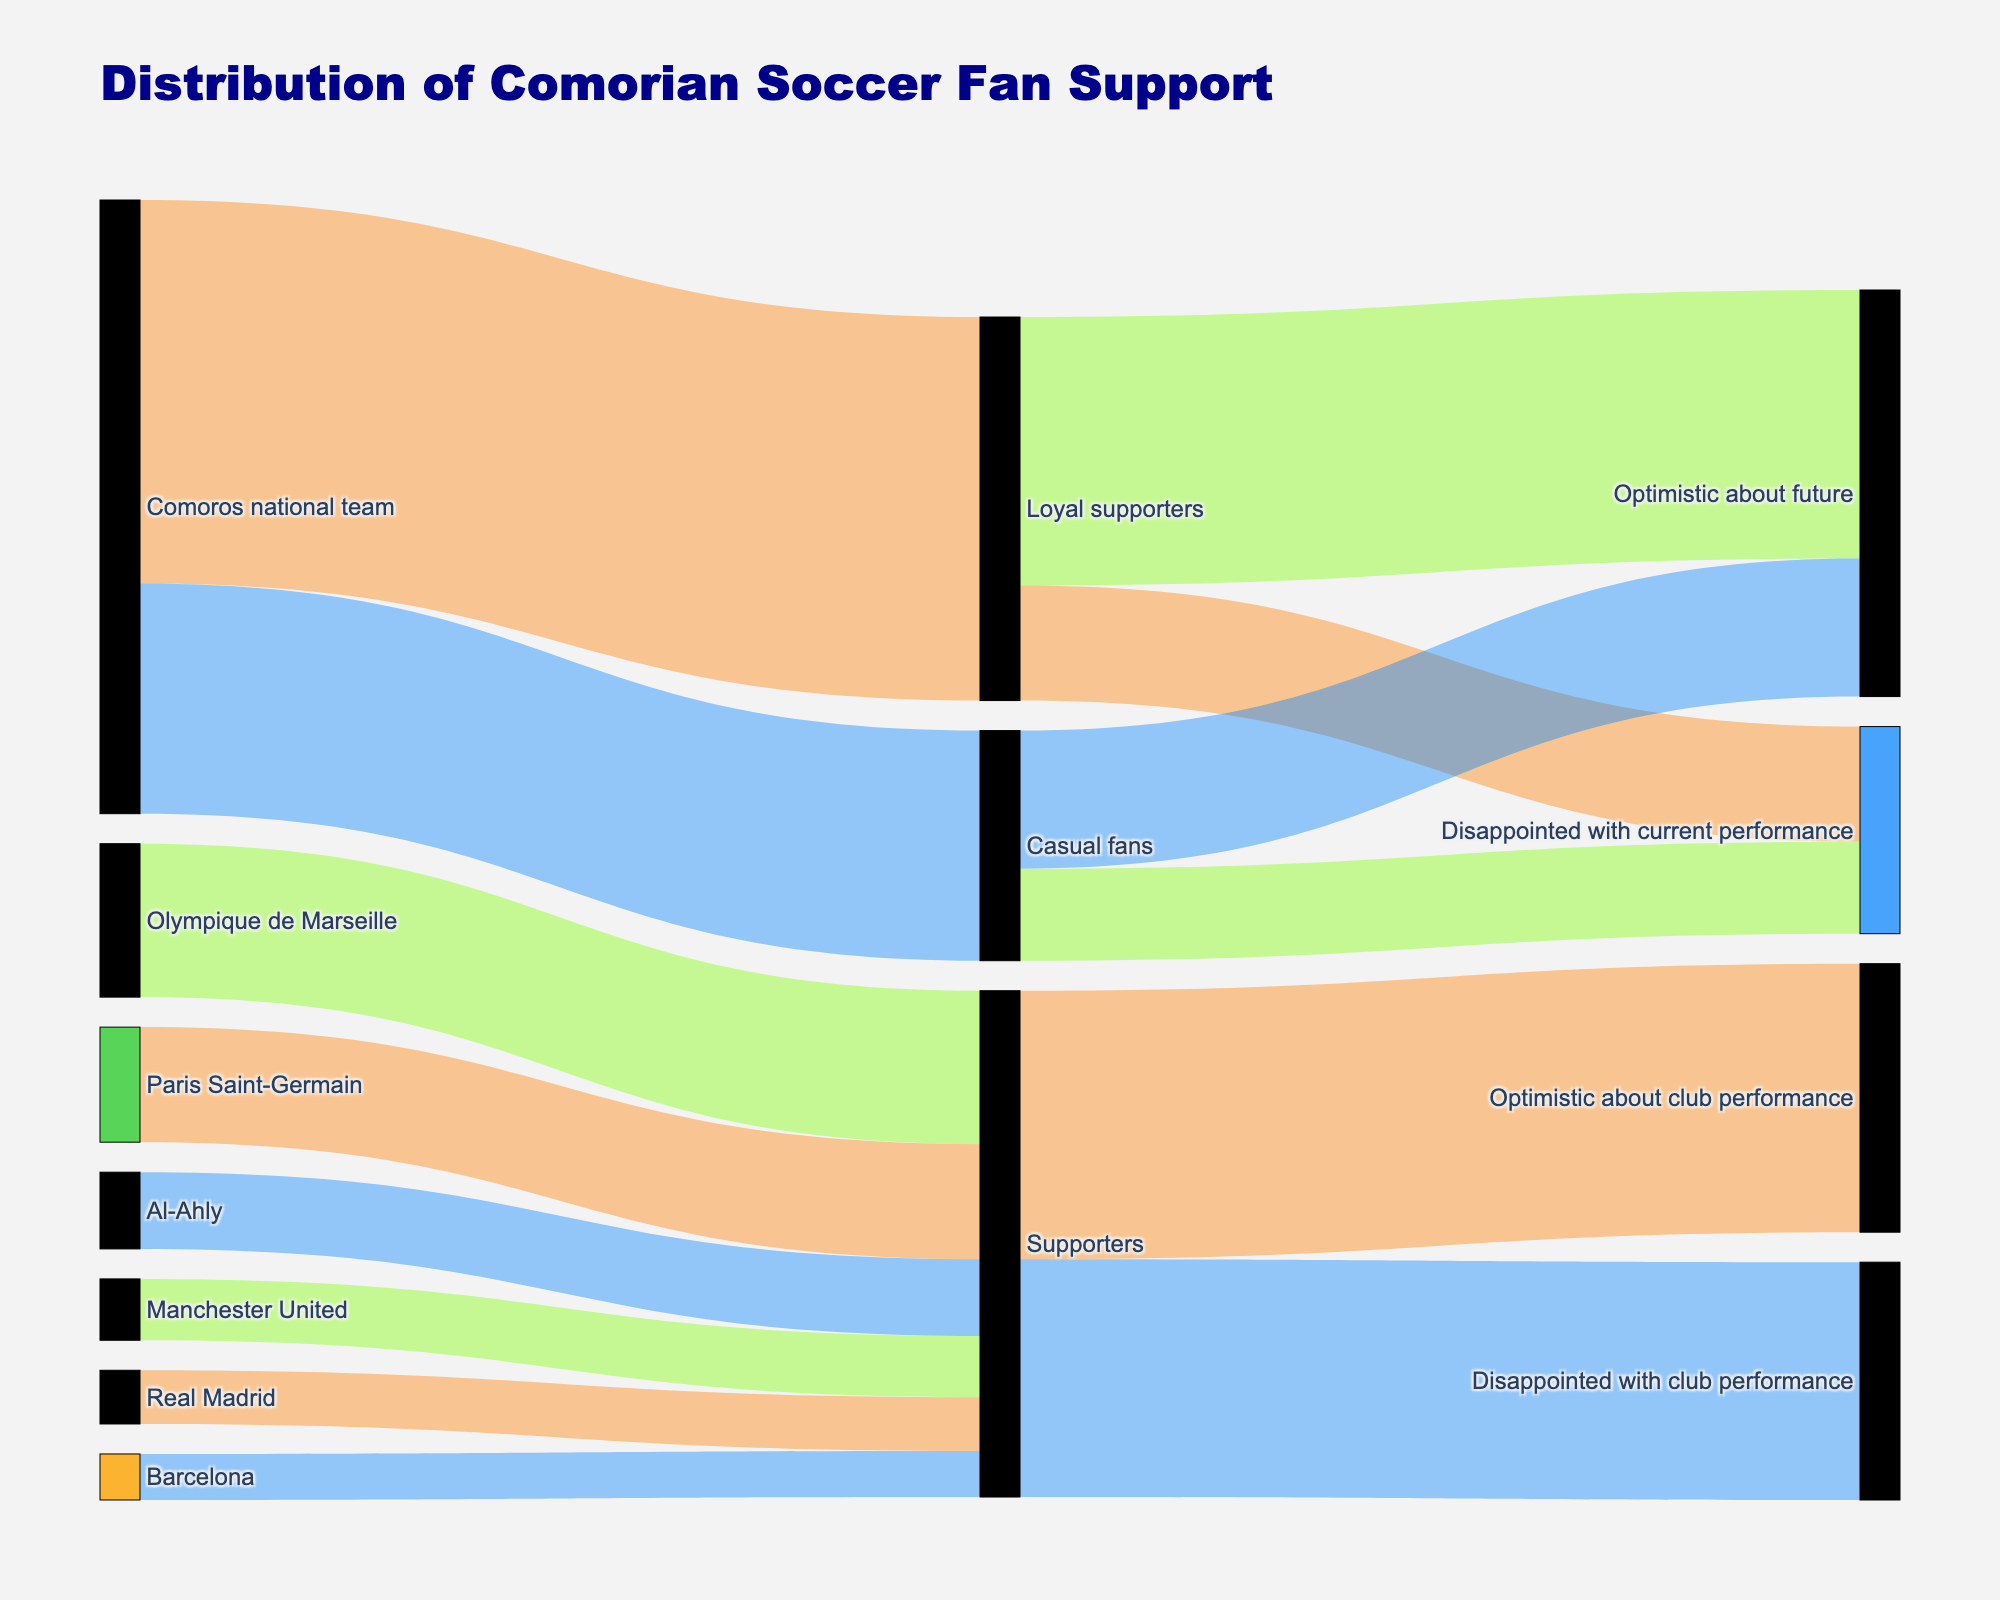What's the title of the figure? The title of the figure is usually displayed at the top in bold and larger font size. In this case, the title at the top of the figure reads "Distribution of Comorian Soccer Fan Support".
Answer: Distribution of Comorian Soccer Fan Support How many loyal supporters of the Comoros national team are optimistic about the future? To find this, locate the link from "Loyal supporters" to "Optimistic about future". The value associated with this link in the data table is 3500.
Answer: 3500 Which category of supporters is disappointed with the club performance and how many do they have? To identify this, look at the link pointing to "Disappointed with club performance". From the data table, the link from "Supporters" to "Disappointed with club performance" has a value of 3100.
Answer: Supporters, 3100 What is the total number of Comorian soccer fans who are disappointed with current performance? Sum the values of both "Loyal supporters" and "Casual fans" who are "Disappointed with current performance": 1500 (Loyal supporters) + 1200 (Casual fans) = 2700.
Answer: 2700 How many supporters are there for Olympique de Marseille compared to Manchester United? Look at the values linked to "Olympique de Marseille" and "Manchester United". "Olympique de Marseille" has 2000 supporters, while "Manchester United" has 800 supporters. 2000 is greater than 800.
Answer: Olympique de Marseille has more supporters than Manchester United What percentage of casual fans are disappointed with the current performance of the Comoros national team? There are 1200 casual fans disappointed with the performance out of a total of 3000 casual fans. To find the percentage: (1200/3000) * 100 = 40%.
Answer: 40% How many total supporters are optimistic about either the national team or club performance? Sum the values for supportive groups optimistic about both the national team and clubs: 3500 (Loyal supporters) + 1800 (Casual fans) + 3500 (Supporters) = 8800.
Answer: 8800 Which international club has the smallest number of supporters and how many? Compare the numbers linked to all international clubs. "Barcelona" has the smallest number with 600 supporters.
Answer: Barcelona, 600 What portion of the total loyal supporters are optimistic about the future? There are 5000 loyal supporters in total. The optimistic part is 3500. So, the fraction is 3500/5000 = 0.7 or 70%.
Answer: 70% 